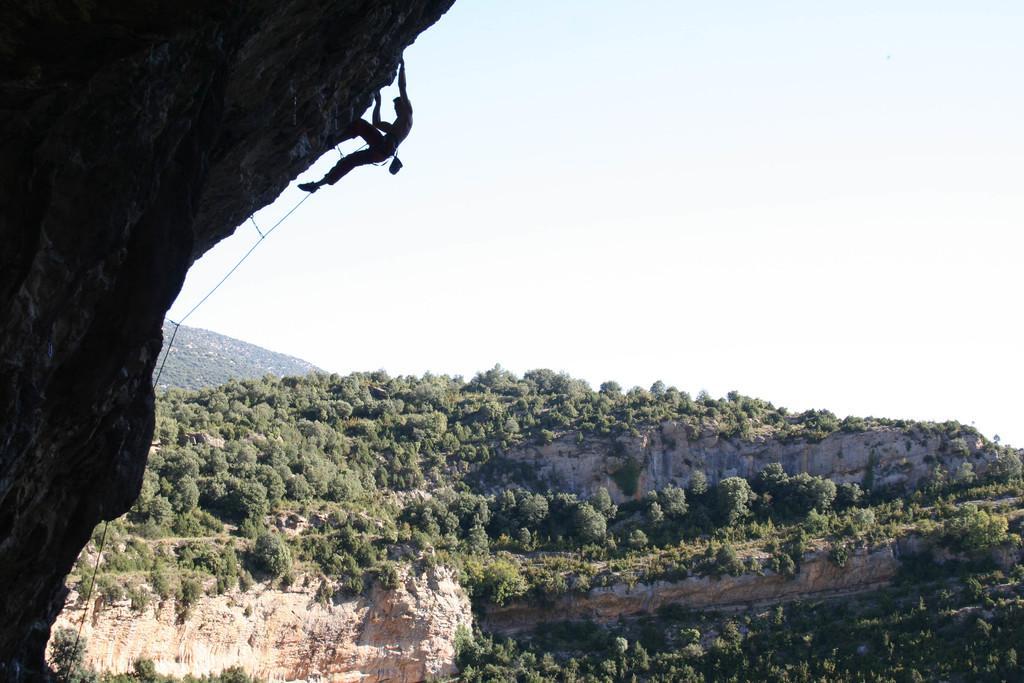How would you summarize this image in a sentence or two? Here a man is climbing a mountain with the help of a rope. In the background we can see trees,mountains and sky. 